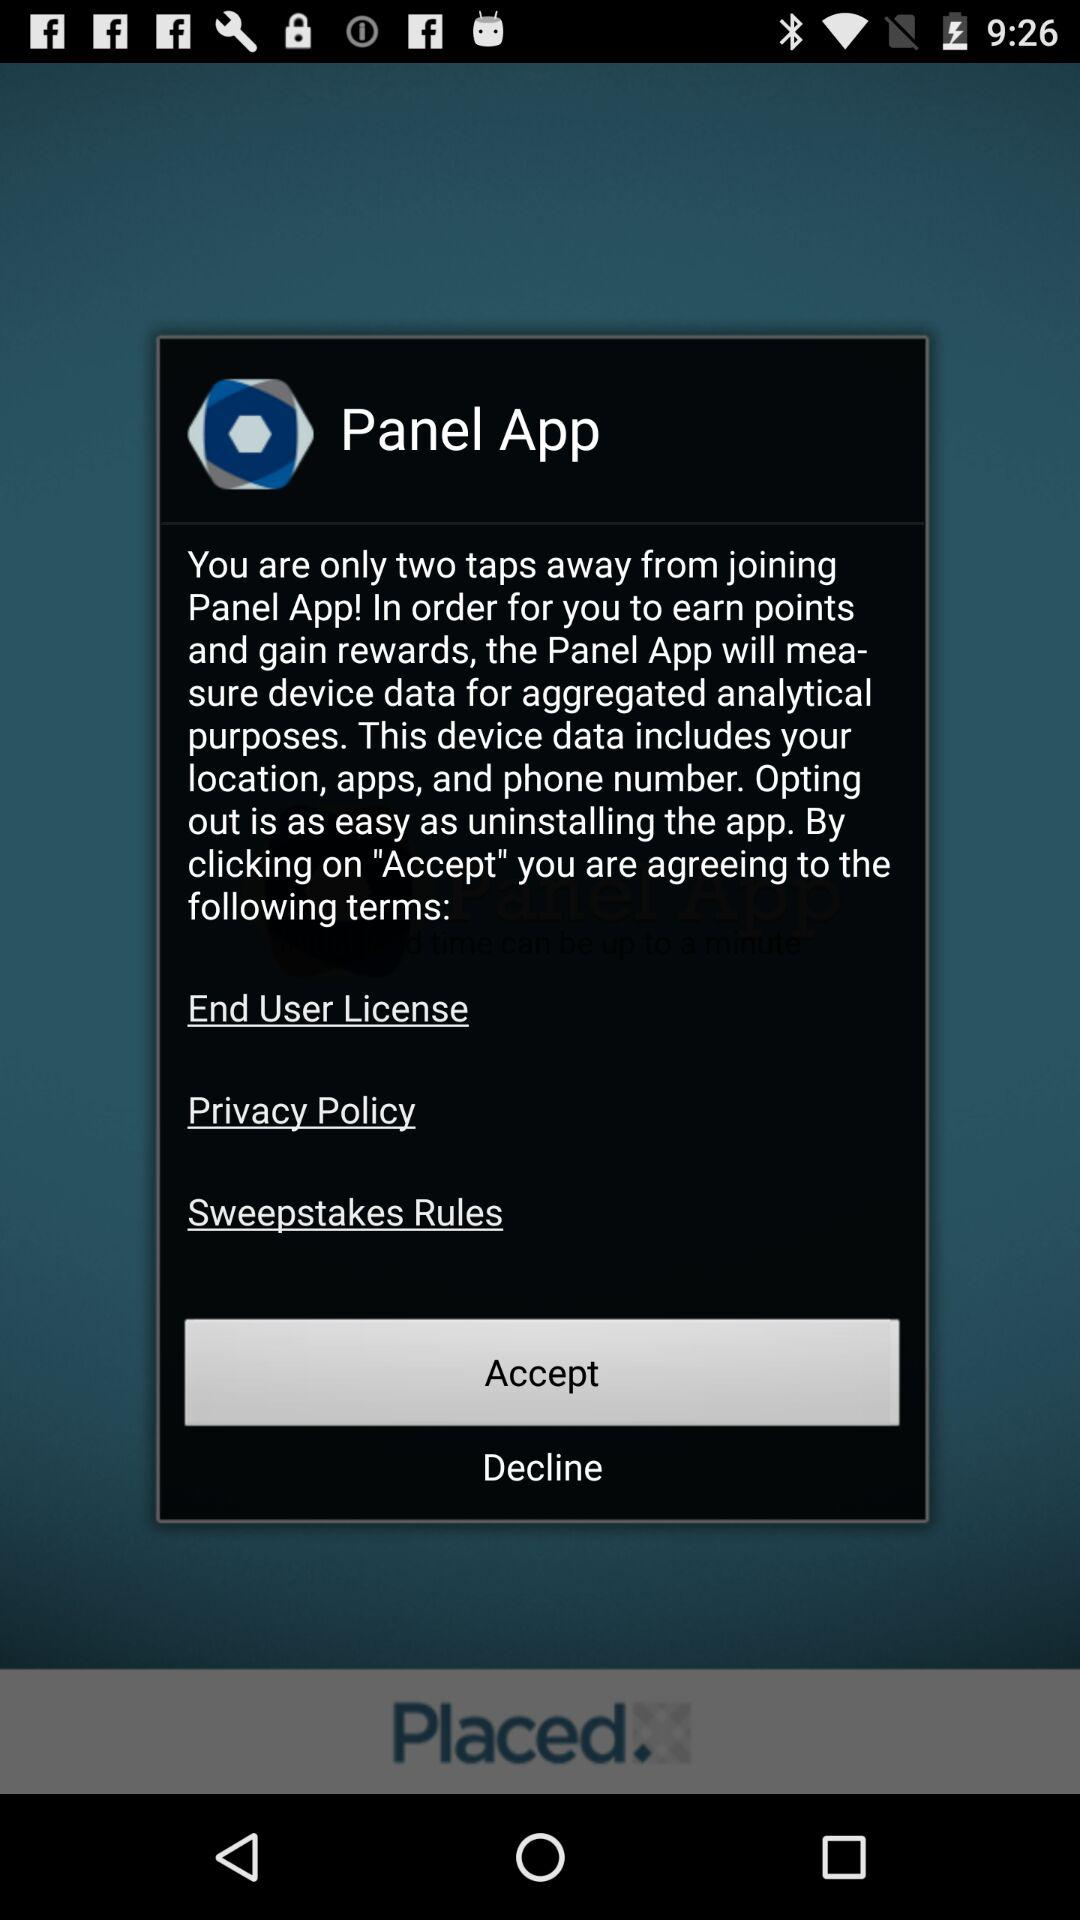How many terms are there in the terms and conditions?
Answer the question using a single word or phrase. 3 